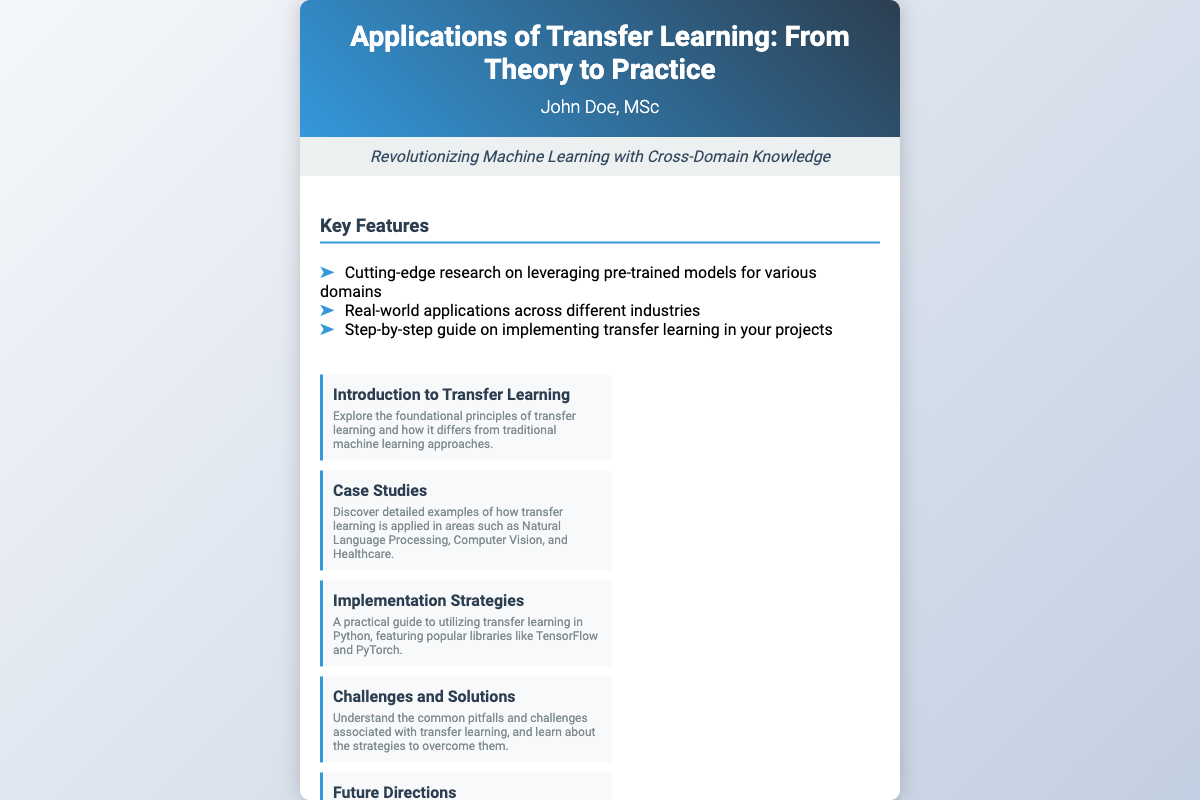what is the title of the book? The title of the book is stated prominently at the top of the cover.
Answer: Applications of Transfer Learning: From Theory to Practice who is the author of the book? The author is listed below the title on the cover.
Answer: John Doe, MSc what is the tagline of the book? The tagline is presented below the author's name and summarizes the book's theme.
Answer: Revolutionizing Machine Learning with Cross-Domain Knowledge how many key features are listed in the document? The number of key features can be found in the list under the "Key Features" section.
Answer: Three name one area highlighted in the case studies section. The case studies section lists specific applications of transfer learning.
Answer: Natural Language Processing what practical guide does the book offer? The implementation strategies section describes the practical guide offered by the book.
Answer: Utilizing transfer learning in Python what is the name of the publisher? The publisher's name is stated at the bottom of the cover.
Answer: TechPress Publishing in which city is the book published? The city of publication is indicated alongside the publisher's name.
Answer: San Francisco what year was the book published? The publication year is provided at the bottom of the cover.
Answer: 2023 